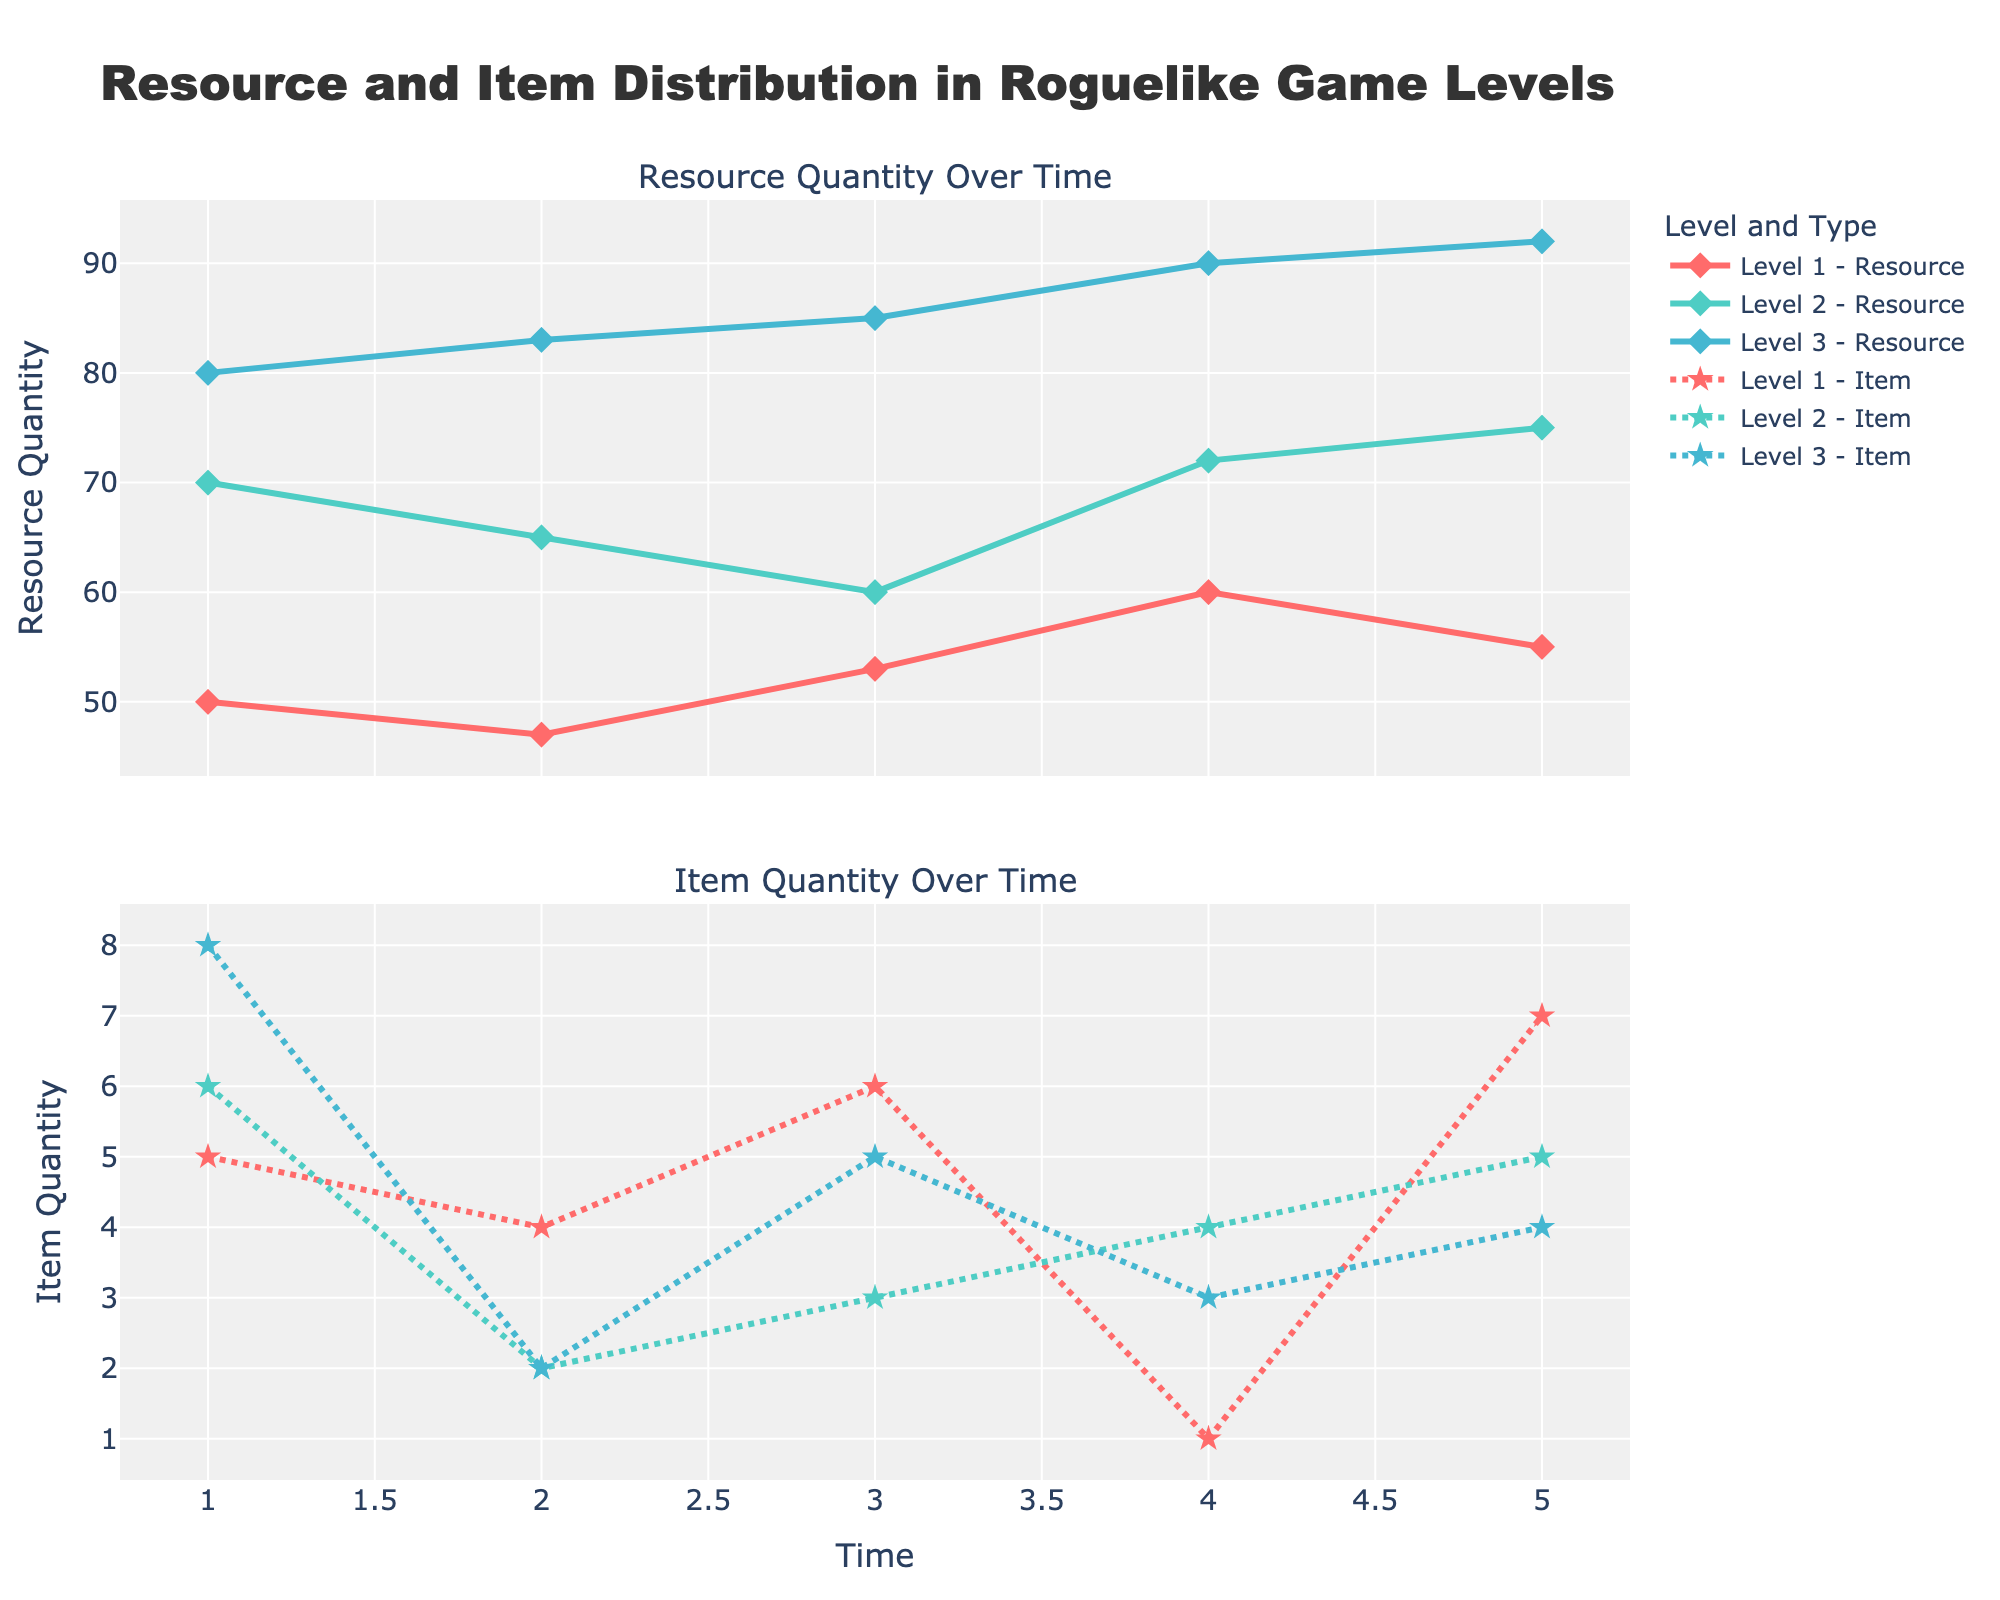what is the title of the figure? The title is displayed at the top of the figure and reads "Resource and Item Distribution in Roguelike Game Levels".
Answer: Resource and Item Distribution in Roguelike Game Levels How many levels are compared in the figure? The figure has three different levels indicated by distinct lines in both subplots, named Level 1, Level 2, and Level 3.
Answer: Three Which level has the highest Resource Quantity at Time 3? At Time 3, the figure shows that Level 3 has the highest Resource Quantity, indicated by the highest point on the Resource Quantity subplot.
Answer: Level 3 What item type has the greatest quantity at Time 4 in Level 2? Time 4 in Level 2 shows that the item type with the greatest quantity is Magic Scroll, as indicated by the highest point in the Item Quantity subplot for Level 2.
Answer: Magic Scroll What is the overall trend of Resource Quantity in Level 1 over time? By observing the trend line in the Resource Quantity subplot for Level 1, one can see that the Resource Quantity fluctuates but generally tends to rise over time.
Answer: Fluctuating but generally rising Compare the Resource Quantities at Time 5 for Level 2 and Level 3. Which is greater? At Time 5, comparing the two lines, Level 3 has a Resource Quantity of 92, while Level 2 has a Resource Quantity of 75. Therefore, Level 3 is greater.
Answer: Level 3 What is the maximum Item Quantity recorded in Level 3? Looking at the highest point on the Item Quantity subplot for Level 3, the maximum Item Quantity recorded is 8.
Answer: 8 Does Level 1 ever have a higher Resource Quantity than Level 2 at the same point in time? At each time point, comparing the Resource Quantity values for Levels 1 and 2 shows that Level 2 always has equal or higher values than Level 1, meaning Level 1 never exceeds Level 2.
Answer: No How does the item distribution pattern in Level 2 compare to that in Level 1 over time? In Level 2, the item distribution starts with Health Potions, followed by a mix of Shields and Magic Scrolls. In Level 1, Health Potions and Mana Potions are more consistently distributed.
Answer: Different items and distribution patterns What trend can be observed for the Item Quantity in Level 3 from Time 1 to Time 5? By following the dotted line on the Item Quantity subplot for Level 3, there is a general fluctuation with a slight upward trend from Time 1 to Time 5.
Answer: Fluctuating with a slight upward trend 